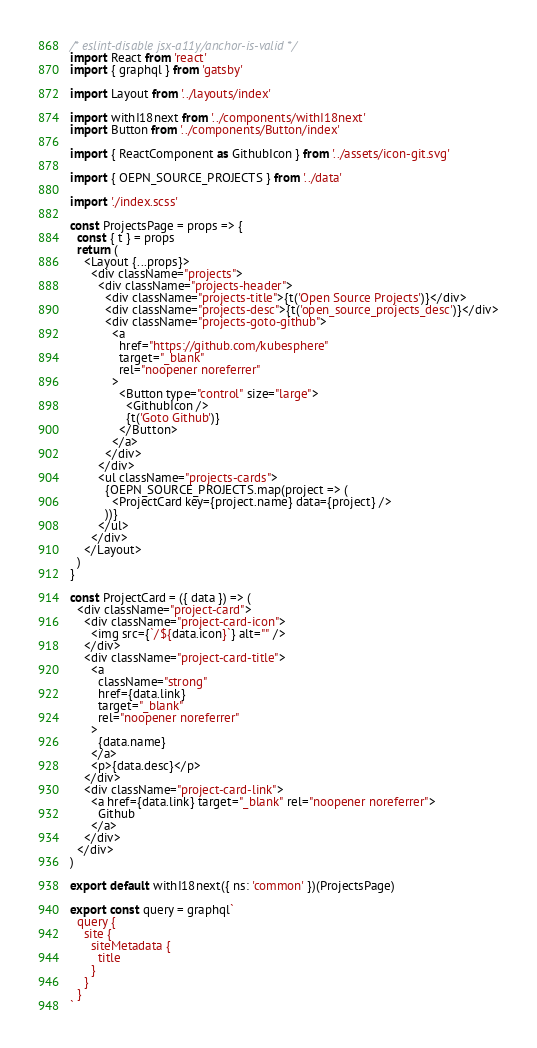Convert code to text. <code><loc_0><loc_0><loc_500><loc_500><_JavaScript_>/* eslint-disable jsx-a11y/anchor-is-valid */
import React from 'react'
import { graphql } from 'gatsby'

import Layout from '../layouts/index'

import withI18next from '../components/withI18next'
import Button from '../components/Button/index'

import { ReactComponent as GithubIcon } from '../assets/icon-git.svg'

import { OEPN_SOURCE_PROJECTS } from '../data'

import './index.scss'

const ProjectsPage = props => {
  const { t } = props
  return (
    <Layout {...props}>
      <div className="projects">
        <div className="projects-header">
          <div className="projects-title">{t('Open Source Projects')}</div>
          <div className="projects-desc">{t('open_source_projects_desc')}</div>
          <div className="projects-goto-github">
            <a
              href="https://github.com/kubesphere"
              target="_blank"
              rel="noopener noreferrer"
            >
              <Button type="control" size="large">
                <GithubIcon />
                {t('Goto Github')}
              </Button>
            </a>
          </div>
        </div>
        <ul className="projects-cards">
          {OEPN_SOURCE_PROJECTS.map(project => (
            <ProjectCard key={project.name} data={project} />
          ))}
        </ul>
      </div>
    </Layout>
  )
}

const ProjectCard = ({ data }) => (
  <div className="project-card">
    <div className="project-card-icon">
      <img src={`/${data.icon}`} alt="" />
    </div>
    <div className="project-card-title">
      <a
        className="strong"
        href={data.link}
        target="_blank"
        rel="noopener noreferrer"
      >
        {data.name}
      </a>
      <p>{data.desc}</p>
    </div>
    <div className="project-card-link">
      <a href={data.link} target="_blank" rel="noopener noreferrer">
        Github
      </a>
    </div>
  </div>
)

export default withI18next({ ns: 'common' })(ProjectsPage)

export const query = graphql`
  query {
    site {
      siteMetadata {
        title
      }
    }
  }
`
</code> 